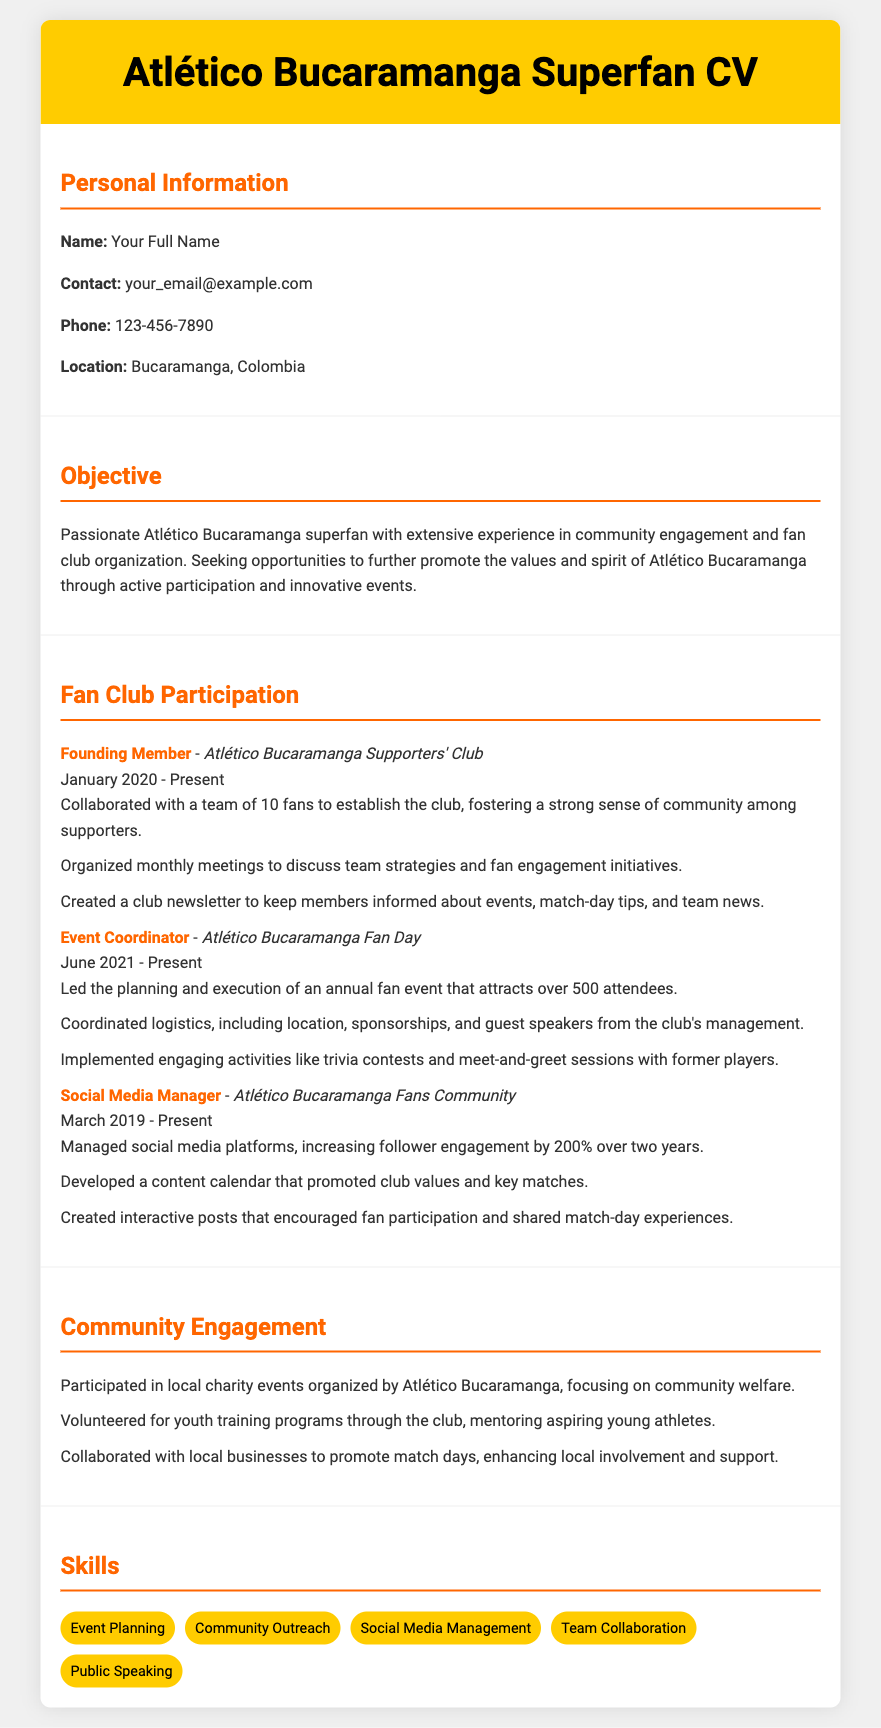What is the role of the individual in the Atlético Bucaramanga Supporters' Club? The role is specified as "Founding Member."
Answer: Founding Member When did the individual start participating in the Atlético Bucaramanga Fan Day? The participation began in June 2021, as stated in the document.
Answer: June 2021 How many attendees does the annual fan event attract? According to the document, the event attracts over 500 attendees.
Answer: Over 500 What significant increase did the Social Media Manager achieve in follower engagement? The document states that follower engagement increased by 200% over two years.
Answer: 200% What is the individual's primary objective in relation to Atlético Bucaramanga? The CV outlines that the objective is to promote the values and spirit of Atlético Bucaramanga.
Answer: Promote values and spirit How many fans collaborated to establish the Atlético Bucaramanga Supporters' Club? The document indicates that a team of 10 fans collaborated to establish the club.
Answer: 10 Which program has the individual volunteered for through the club? The document mentions volunteering for youth training programs.
Answer: Youth training programs 